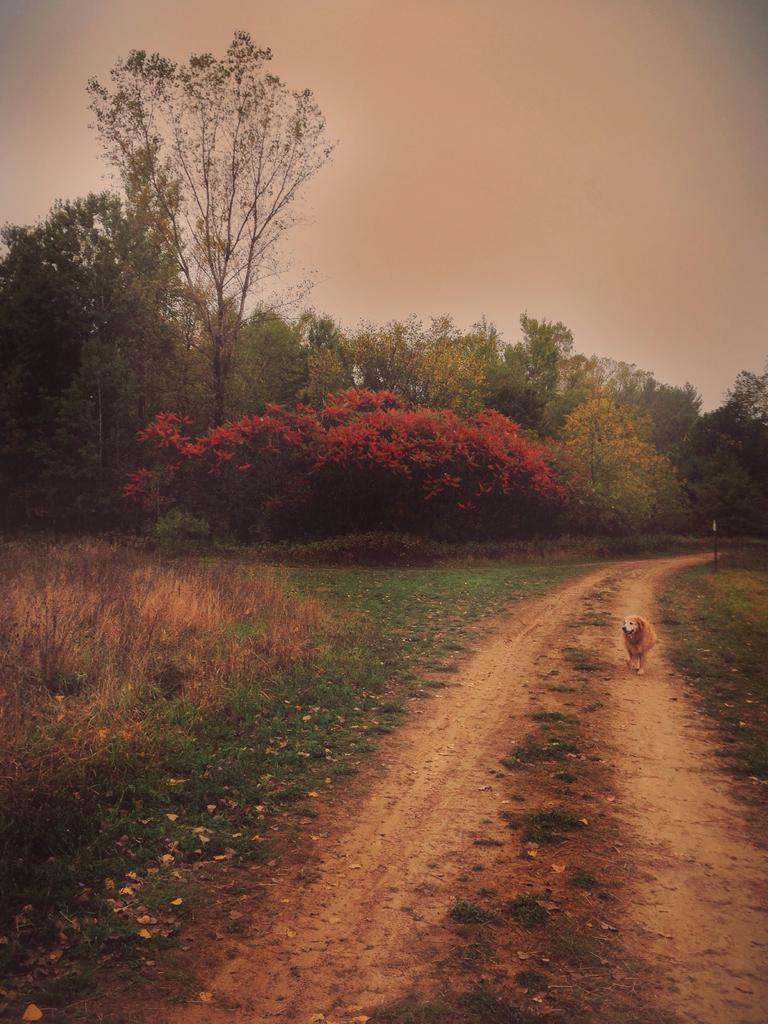What animal is located on the right side of the image? There is a dog on the right side of the image. What type of vegetation is at the bottom of the image? There are plants and grass at the bottom of the image. What can be seen in the background of the image? There are trees and the sky visible in the background of the image. How many horses are present in the image? There are no horses present in the image; it features a dog. What type of stamp can be seen on the dog's collar in the image? There is no stamp or collar visible on the dog in the image. 